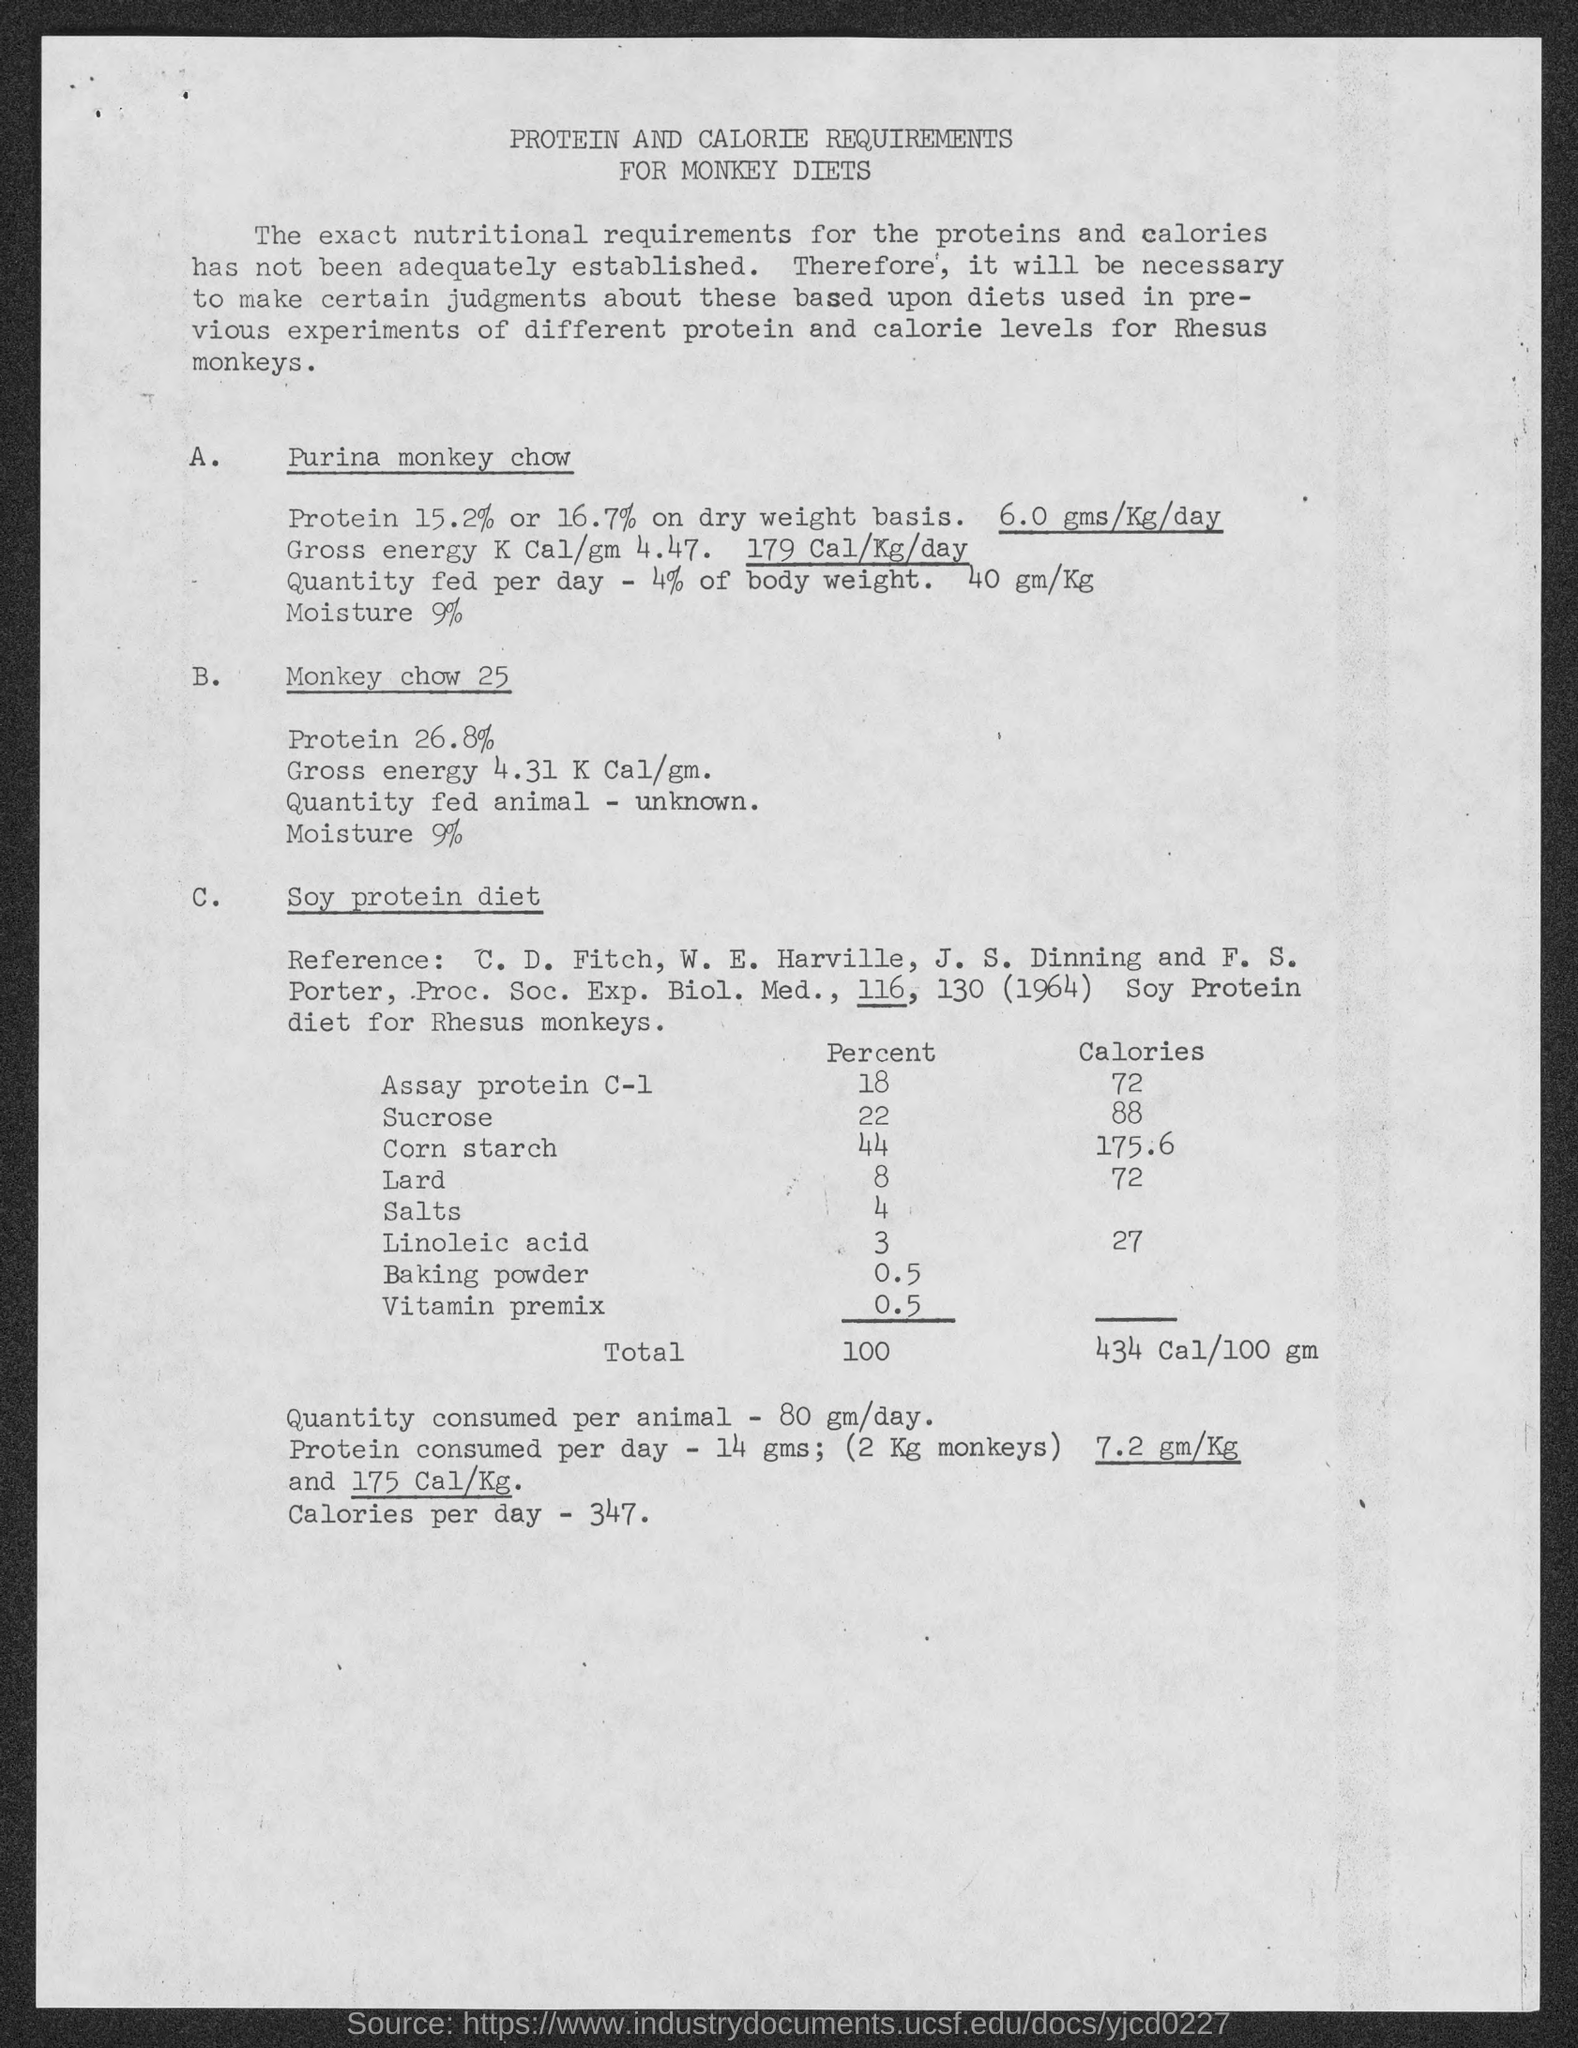What is the quantity consumed per animal?
Your answer should be compact. 80 gm/day. How much protein is consumed per day?
Give a very brief answer. 14 gms. How much calories per day?
Provide a succinct answer. 347. What is the title of  the document?
Provide a succinct answer. Protein and calorie requirements for monkey diets. 